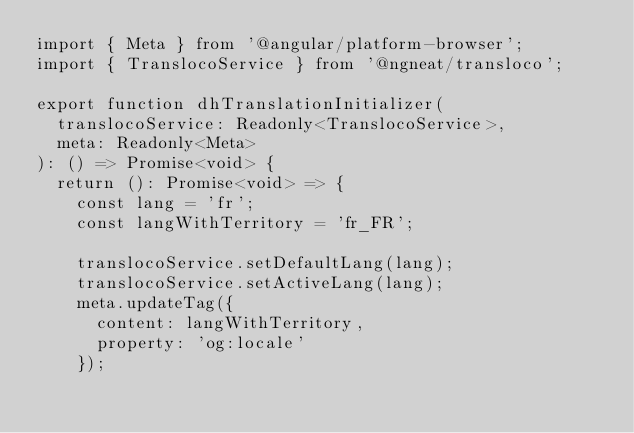Convert code to text. <code><loc_0><loc_0><loc_500><loc_500><_TypeScript_>import { Meta } from '@angular/platform-browser';
import { TranslocoService } from '@ngneat/transloco';

export function dhTranslationInitializer(
  translocoService: Readonly<TranslocoService>,
  meta: Readonly<Meta>
): () => Promise<void> {
  return (): Promise<void> => {
    const lang = 'fr';
    const langWithTerritory = 'fr_FR';

    translocoService.setDefaultLang(lang);
    translocoService.setActiveLang(lang);
    meta.updateTag({
      content: langWithTerritory,
      property: 'og:locale'
    });
</code> 